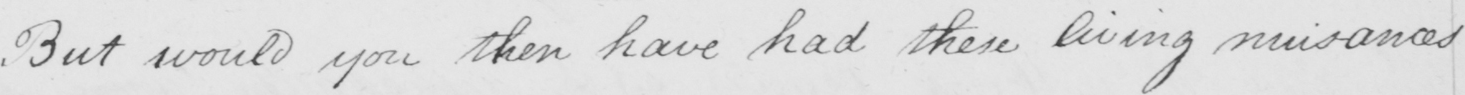Please provide the text content of this handwritten line. But would you then have had these living nuisances 